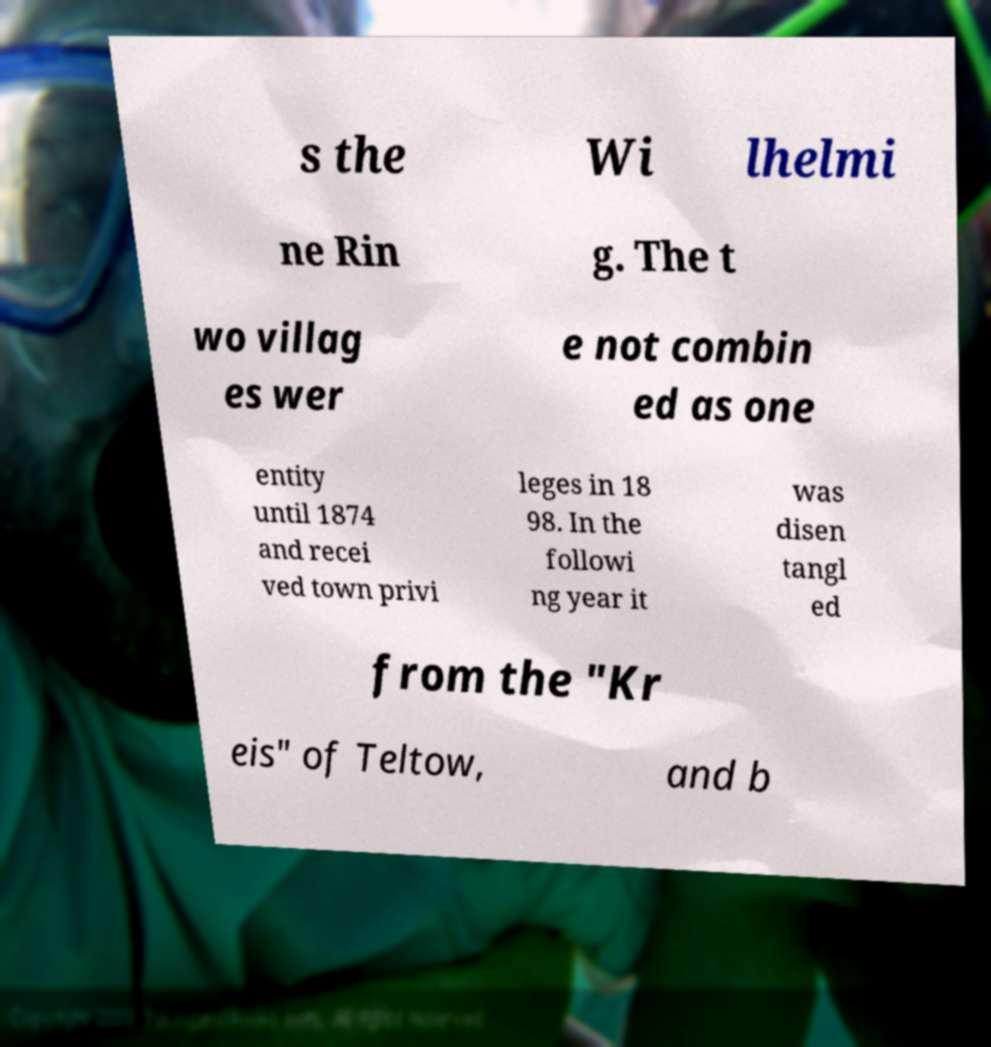What messages or text are displayed in this image? I need them in a readable, typed format. s the Wi lhelmi ne Rin g. The t wo villag es wer e not combin ed as one entity until 1874 and recei ved town privi leges in 18 98. In the followi ng year it was disen tangl ed from the "Kr eis" of Teltow, and b 